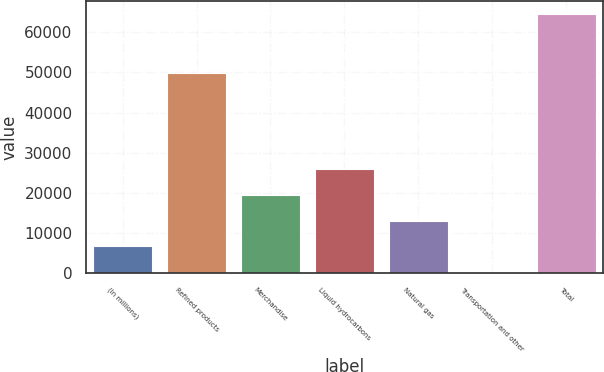Convert chart. <chart><loc_0><loc_0><loc_500><loc_500><bar_chart><fcel>(In millions)<fcel>Refined products<fcel>Merchandise<fcel>Liquid hydrocarbons<fcel>Natural gas<fcel>Transportation and other<fcel>Total<nl><fcel>6735.1<fcel>49718<fcel>19583.3<fcel>26007.4<fcel>13159.2<fcel>311<fcel>64552<nl></chart> 